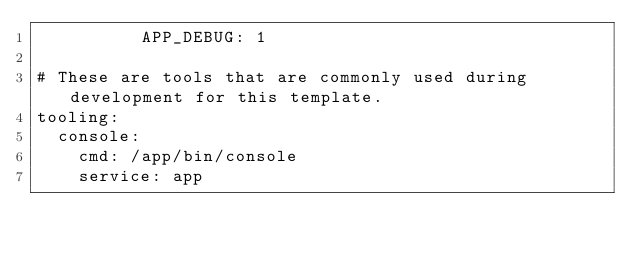<code> <loc_0><loc_0><loc_500><loc_500><_YAML_>          APP_DEBUG: 1

# These are tools that are commonly used during development for this template.
tooling:
  console:
    cmd: /app/bin/console
    service: app
</code> 